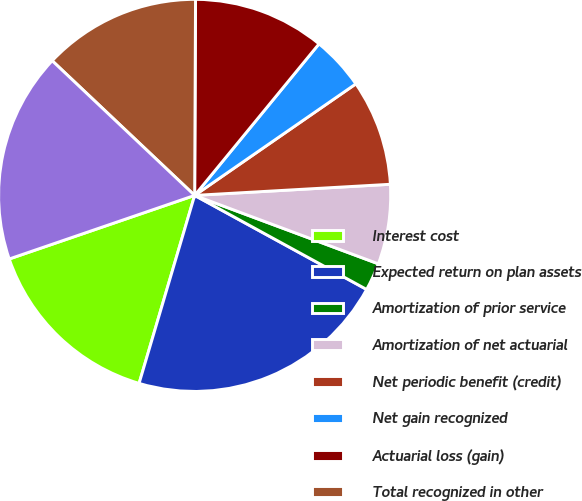Convert chart to OTSL. <chart><loc_0><loc_0><loc_500><loc_500><pie_chart><fcel>Interest cost<fcel>Expected return on plan assets<fcel>Amortization of prior service<fcel>Amortization of net actuarial<fcel>Net periodic benefit (credit)<fcel>Net gain recognized<fcel>Actuarial loss (gain)<fcel>Total recognized in other<fcel>Total recognized in net<nl><fcel>15.17%<fcel>21.61%<fcel>2.29%<fcel>6.58%<fcel>8.73%<fcel>4.43%<fcel>10.87%<fcel>13.02%<fcel>17.31%<nl></chart> 